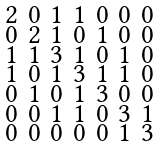Convert formula to latex. <formula><loc_0><loc_0><loc_500><loc_500>\begin{smallmatrix} 2 & 0 & 1 & 1 & 0 & 0 & 0 \\ 0 & 2 & 1 & 0 & 1 & 0 & 0 \\ 1 & 1 & 3 & 1 & 0 & 1 & 0 \\ 1 & 0 & 1 & 3 & 1 & 1 & 0 \\ 0 & 1 & 0 & 1 & 3 & 0 & 0 \\ 0 & 0 & 1 & 1 & 0 & 3 & 1 \\ 0 & 0 & 0 & 0 & 0 & 1 & 3 \end{smallmatrix}</formula> 